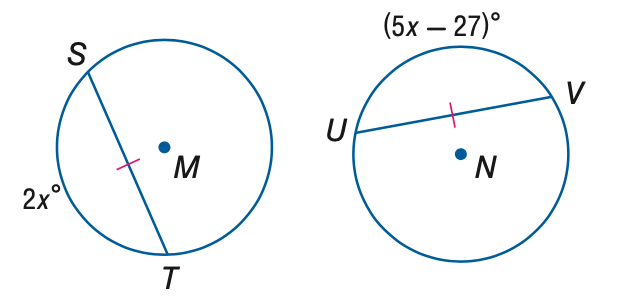Answer the mathemtical geometry problem and directly provide the correct option letter.
Question: Find x if \odot M \cong \odot N.
Choices: A: 8 B: 9 C: 10 D: 12 B 